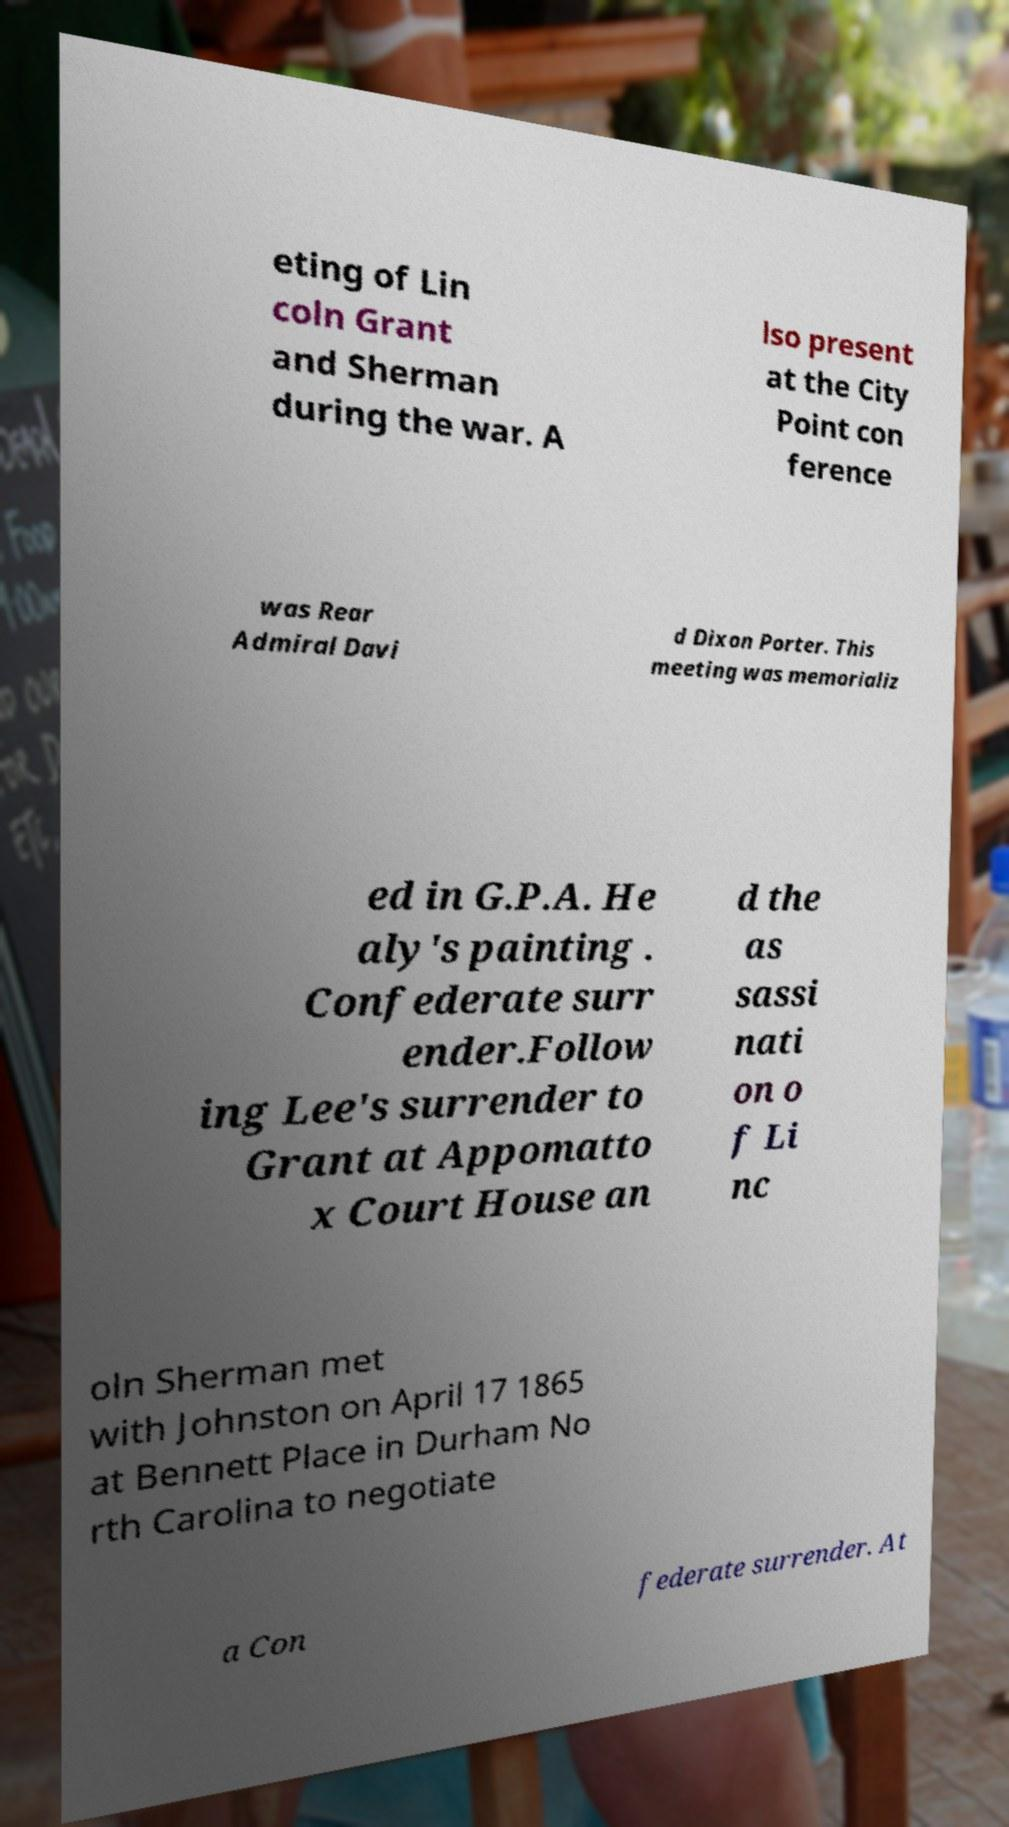Please identify and transcribe the text found in this image. eting of Lin coln Grant and Sherman during the war. A lso present at the City Point con ference was Rear Admiral Davi d Dixon Porter. This meeting was memorializ ed in G.P.A. He aly's painting . Confederate surr ender.Follow ing Lee's surrender to Grant at Appomatto x Court House an d the as sassi nati on o f Li nc oln Sherman met with Johnston on April 17 1865 at Bennett Place in Durham No rth Carolina to negotiate a Con federate surrender. At 